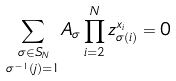Convert formula to latex. <formula><loc_0><loc_0><loc_500><loc_500>\underset { \sigma ^ { - 1 } ( j ) = 1 } { \sum _ { \sigma \in S _ { N } } } A _ { \sigma } \prod _ { i = 2 } ^ { N } z _ { \sigma ( i ) } ^ { x _ { i } } = 0</formula> 